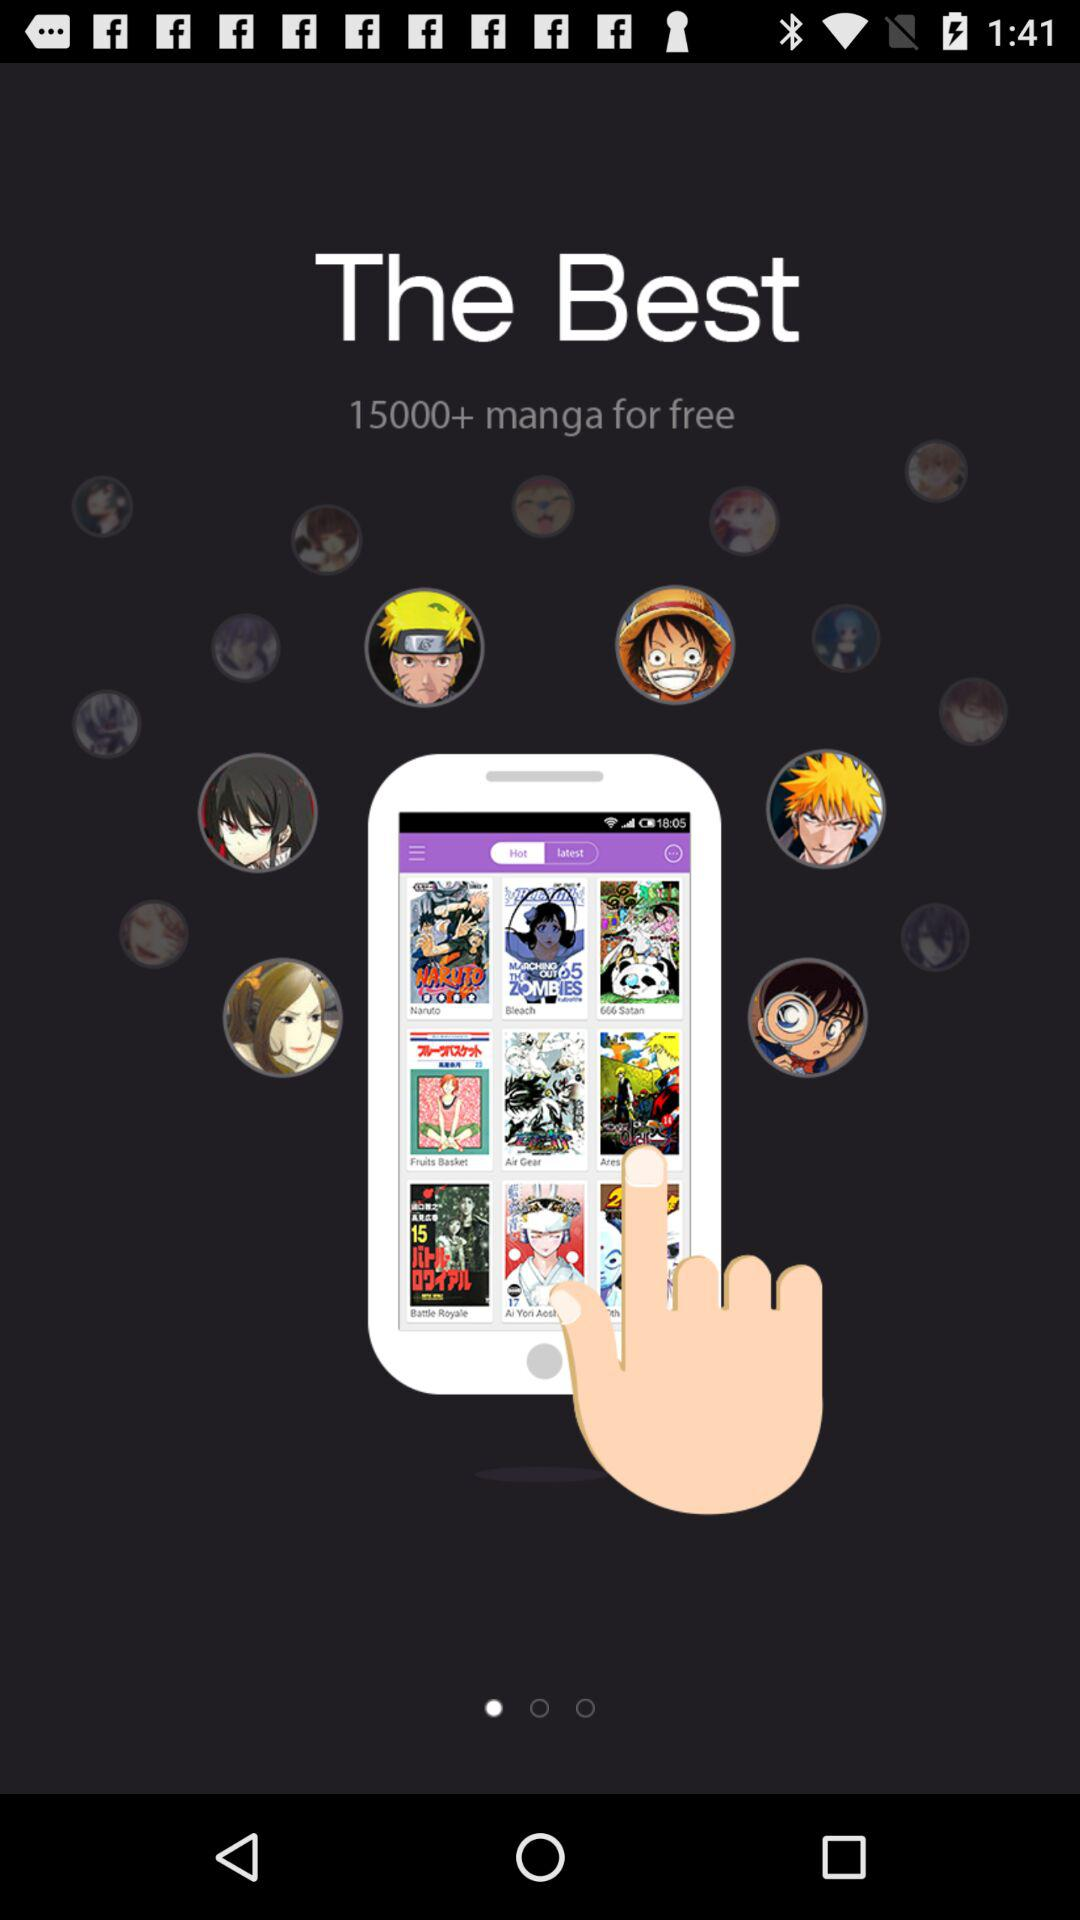How many manga are free? There are more than 15000 manga free. 